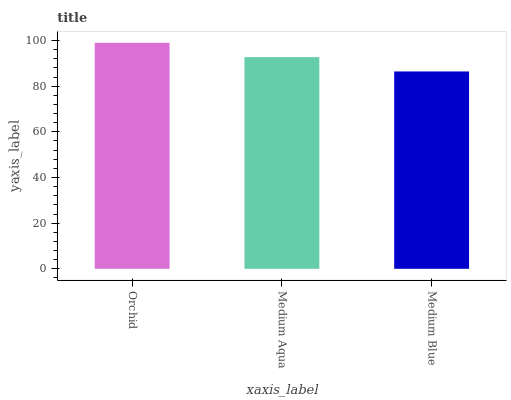Is Medium Blue the minimum?
Answer yes or no. Yes. Is Orchid the maximum?
Answer yes or no. Yes. Is Medium Aqua the minimum?
Answer yes or no. No. Is Medium Aqua the maximum?
Answer yes or no. No. Is Orchid greater than Medium Aqua?
Answer yes or no. Yes. Is Medium Aqua less than Orchid?
Answer yes or no. Yes. Is Medium Aqua greater than Orchid?
Answer yes or no. No. Is Orchid less than Medium Aqua?
Answer yes or no. No. Is Medium Aqua the high median?
Answer yes or no. Yes. Is Medium Aqua the low median?
Answer yes or no. Yes. Is Medium Blue the high median?
Answer yes or no. No. Is Medium Blue the low median?
Answer yes or no. No. 